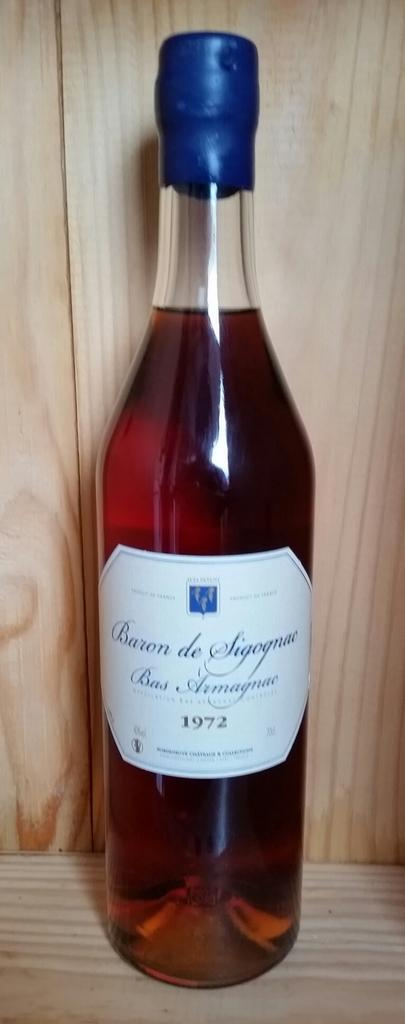<image>
Share a concise interpretation of the image provided. the year 1972 is on one of the bottles 